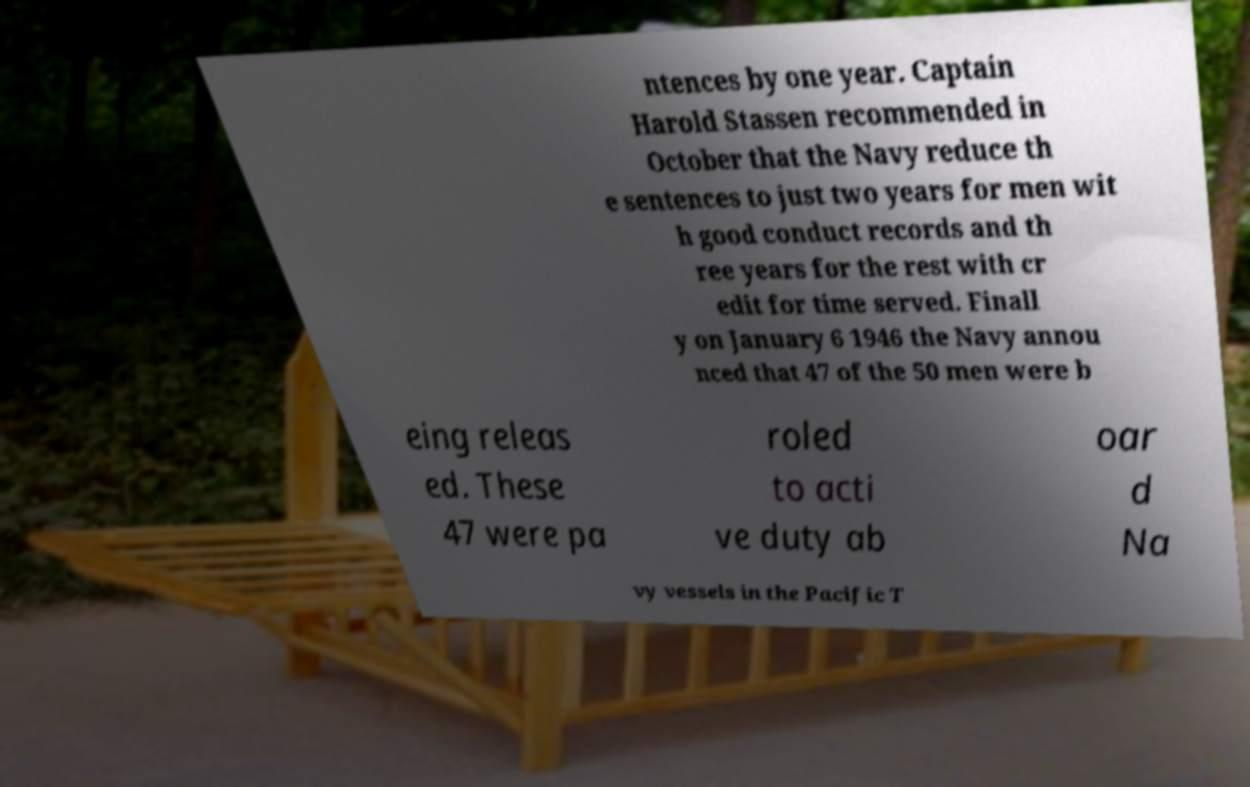What messages or text are displayed in this image? I need them in a readable, typed format. ntences by one year. Captain Harold Stassen recommended in October that the Navy reduce th e sentences to just two years for men wit h good conduct records and th ree years for the rest with cr edit for time served. Finall y on January 6 1946 the Navy annou nced that 47 of the 50 men were b eing releas ed. These 47 were pa roled to acti ve duty ab oar d Na vy vessels in the Pacific T 